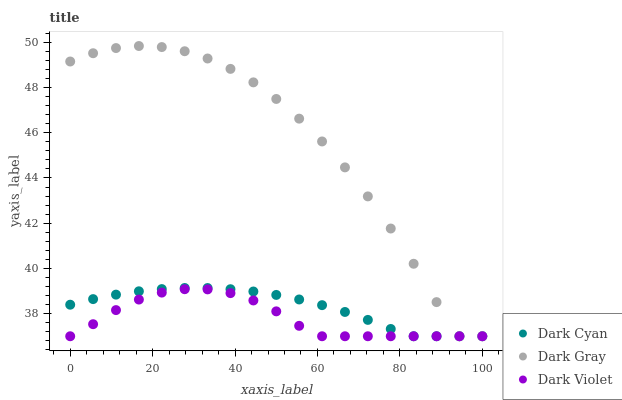Does Dark Violet have the minimum area under the curve?
Answer yes or no. Yes. Does Dark Gray have the maximum area under the curve?
Answer yes or no. Yes. Does Dark Gray have the minimum area under the curve?
Answer yes or no. No. Does Dark Violet have the maximum area under the curve?
Answer yes or no. No. Is Dark Cyan the smoothest?
Answer yes or no. Yes. Is Dark Gray the roughest?
Answer yes or no. Yes. Is Dark Violet the smoothest?
Answer yes or no. No. Is Dark Violet the roughest?
Answer yes or no. No. Does Dark Cyan have the lowest value?
Answer yes or no. Yes. Does Dark Gray have the highest value?
Answer yes or no. Yes. Does Dark Violet have the highest value?
Answer yes or no. No. Does Dark Cyan intersect Dark Violet?
Answer yes or no. Yes. Is Dark Cyan less than Dark Violet?
Answer yes or no. No. Is Dark Cyan greater than Dark Violet?
Answer yes or no. No. 